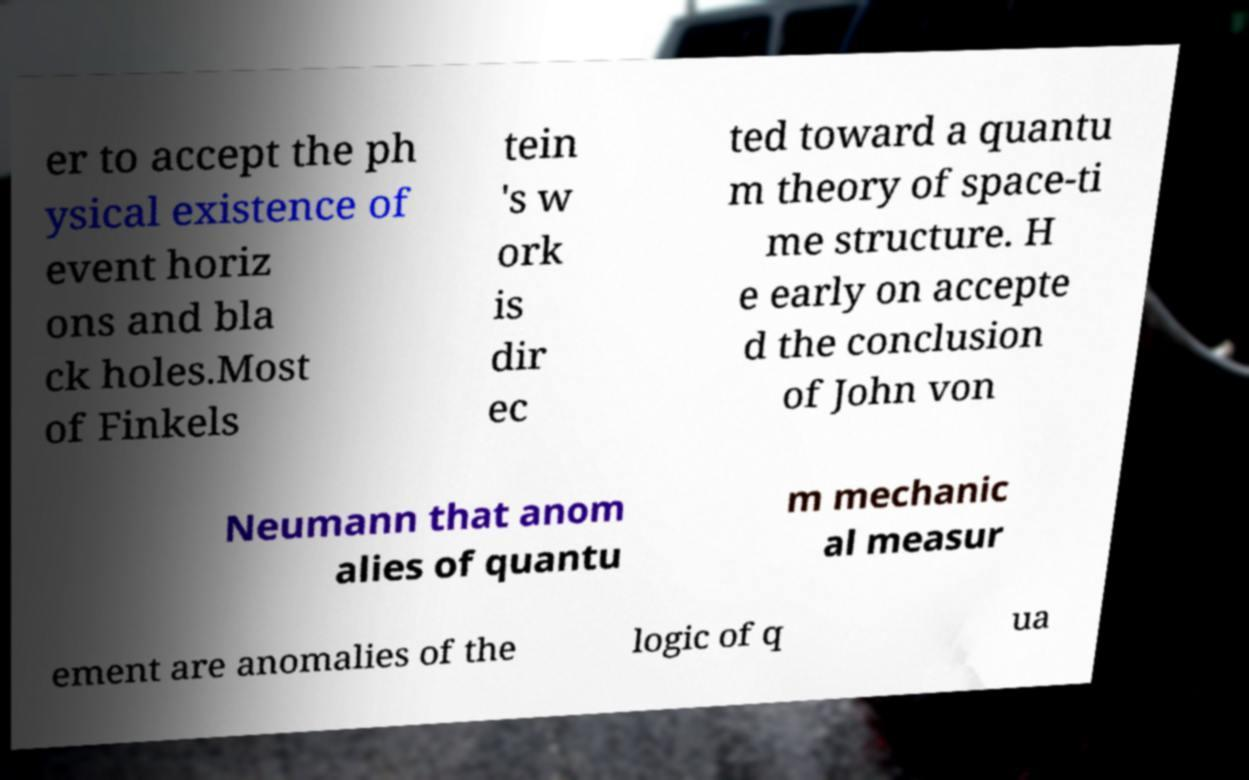For documentation purposes, I need the text within this image transcribed. Could you provide that? er to accept the ph ysical existence of event horiz ons and bla ck holes.Most of Finkels tein 's w ork is dir ec ted toward a quantu m theory of space-ti me structure. H e early on accepte d the conclusion of John von Neumann that anom alies of quantu m mechanic al measur ement are anomalies of the logic of q ua 